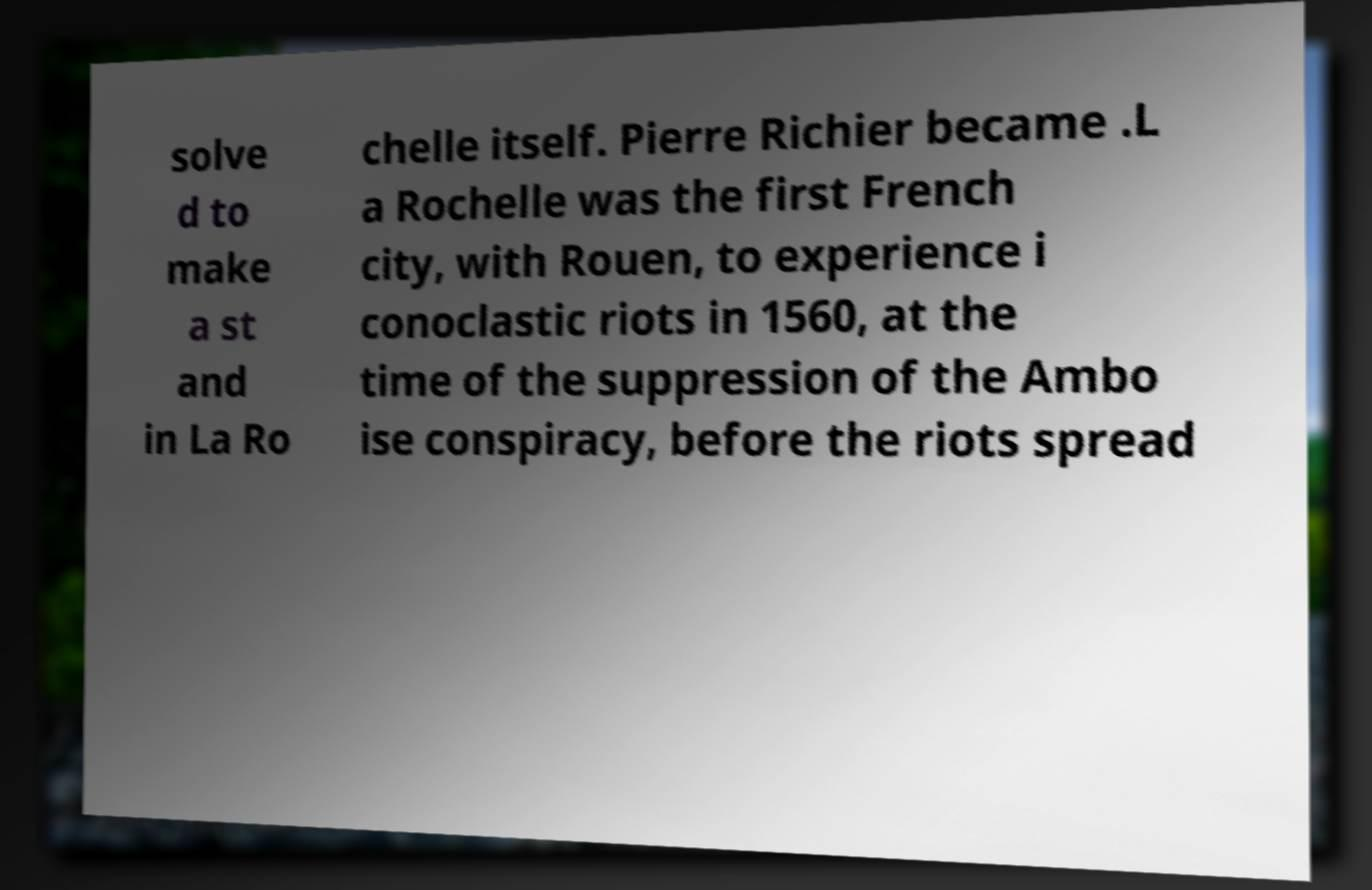Can you accurately transcribe the text from the provided image for me? solve d to make a st and in La Ro chelle itself. Pierre Richier became .L a Rochelle was the first French city, with Rouen, to experience i conoclastic riots in 1560, at the time of the suppression of the Ambo ise conspiracy, before the riots spread 